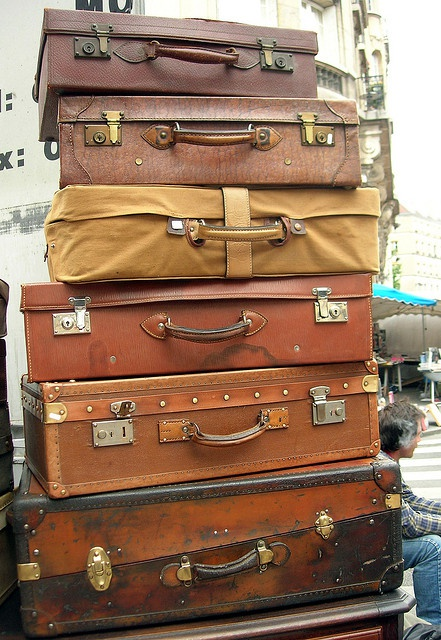Describe the objects in this image and their specific colors. I can see suitcase in lightgray, black, maroon, and brown tones, suitcase in lightgray, brown, salmon, maroon, and tan tones, suitcase in lightgray, brown, maroon, and black tones, suitcase in lightgray, tan, and olive tones, and suitcase in lightgray, gray, tan, and black tones in this image. 